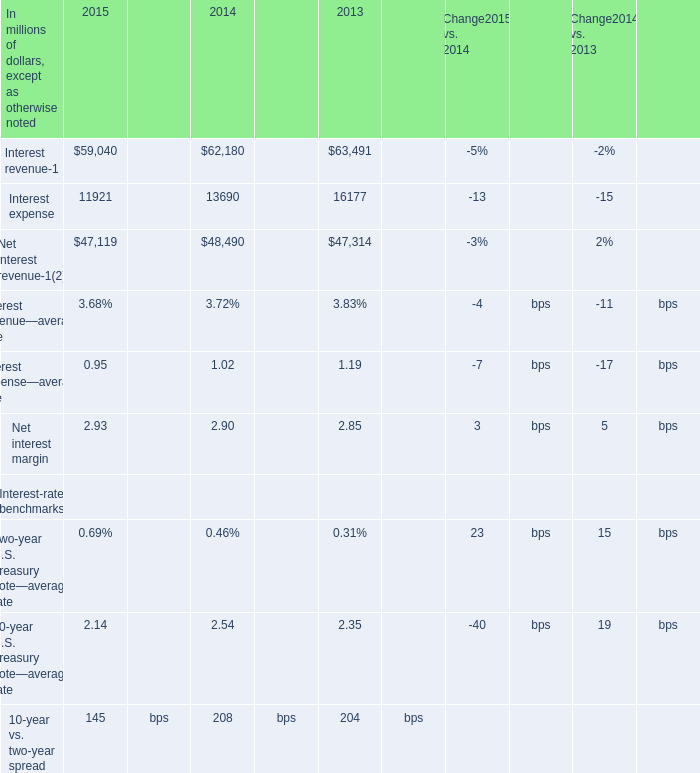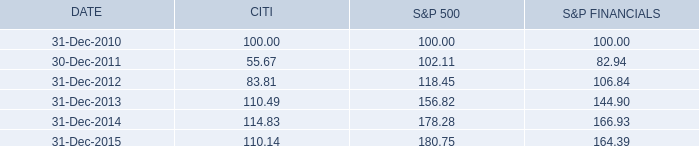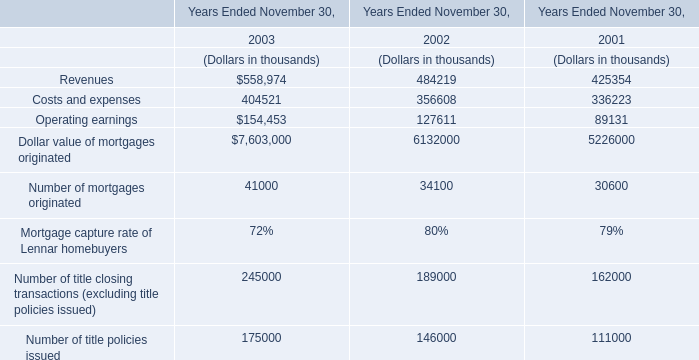what was the percentage cumulative total return of citi common stock for the five years ended 31-dec-2015? 
Computations: ((110.14 - 100) / 100)
Answer: 0.1014. 